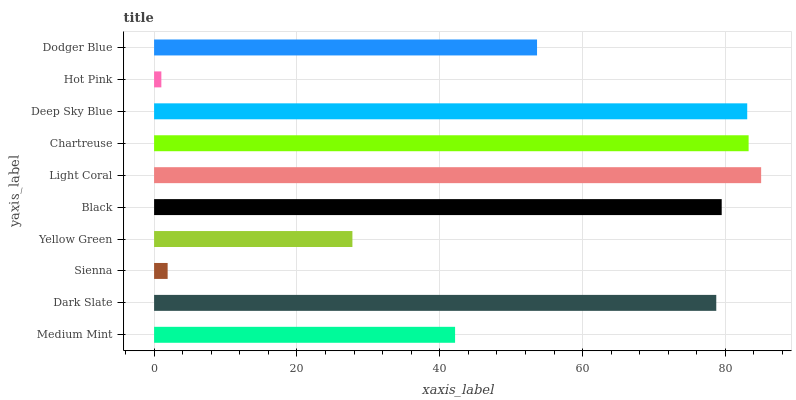Is Hot Pink the minimum?
Answer yes or no. Yes. Is Light Coral the maximum?
Answer yes or no. Yes. Is Dark Slate the minimum?
Answer yes or no. No. Is Dark Slate the maximum?
Answer yes or no. No. Is Dark Slate greater than Medium Mint?
Answer yes or no. Yes. Is Medium Mint less than Dark Slate?
Answer yes or no. Yes. Is Medium Mint greater than Dark Slate?
Answer yes or no. No. Is Dark Slate less than Medium Mint?
Answer yes or no. No. Is Dark Slate the high median?
Answer yes or no. Yes. Is Dodger Blue the low median?
Answer yes or no. Yes. Is Dodger Blue the high median?
Answer yes or no. No. Is Dark Slate the low median?
Answer yes or no. No. 